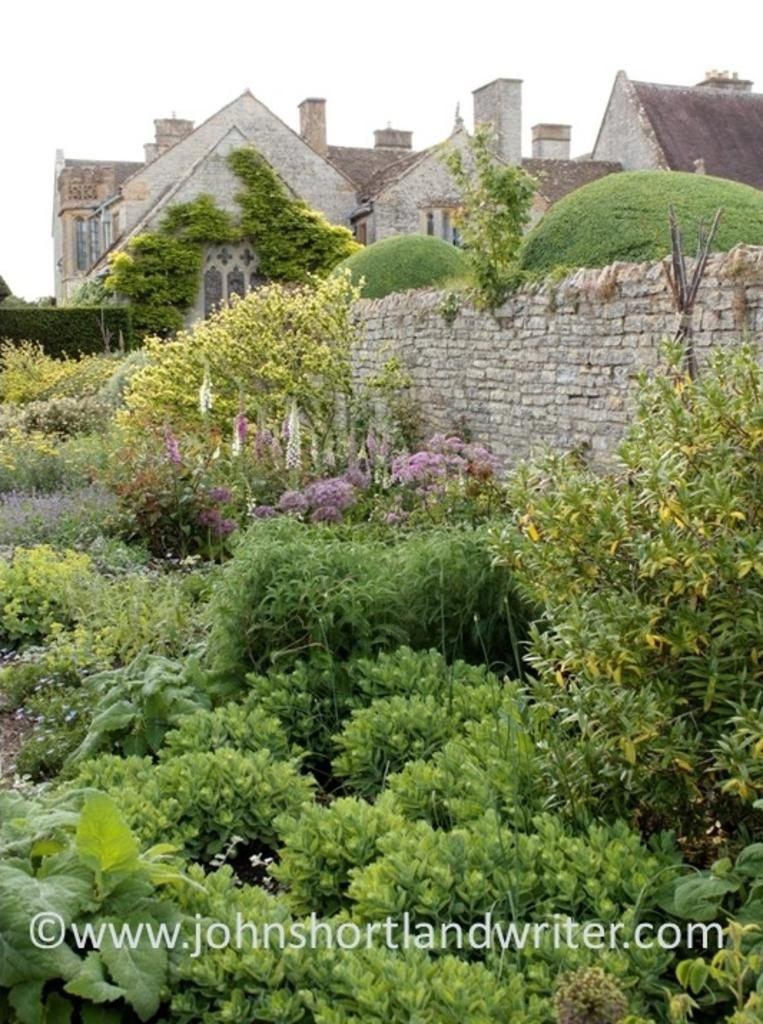What type of plants can be seen in the image? There are green color plants in the image. What structure is present in the image? There is a building in the image. Can you describe any additional features of the image? There is a watermark in the image. Who is the owner of the cherry tree in the image? There is no cherry tree present in the image, so it is not possible to determine the owner. 